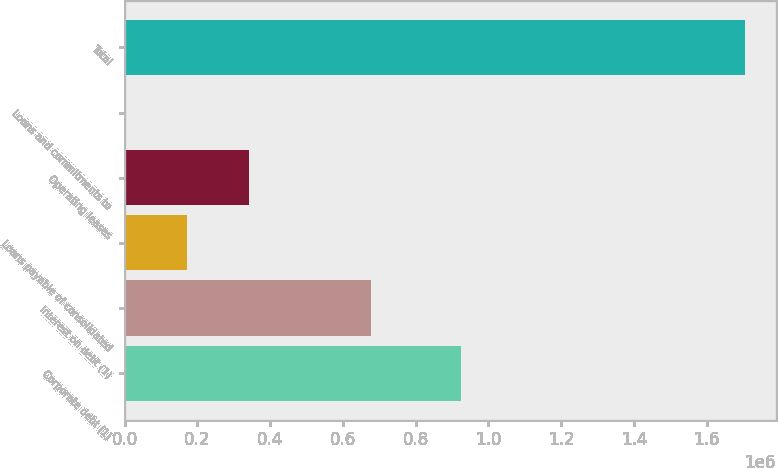Convert chart. <chart><loc_0><loc_0><loc_500><loc_500><bar_chart><fcel>Corporate debt (1)<fcel>Interest on debt (1)<fcel>Loans payable of consolidated<fcel>Operating leases<fcel>Loans and commitments to<fcel>Total<nl><fcel>923482<fcel>677700<fcel>170495<fcel>340866<fcel>123<fcel>1.70384e+06<nl></chart> 